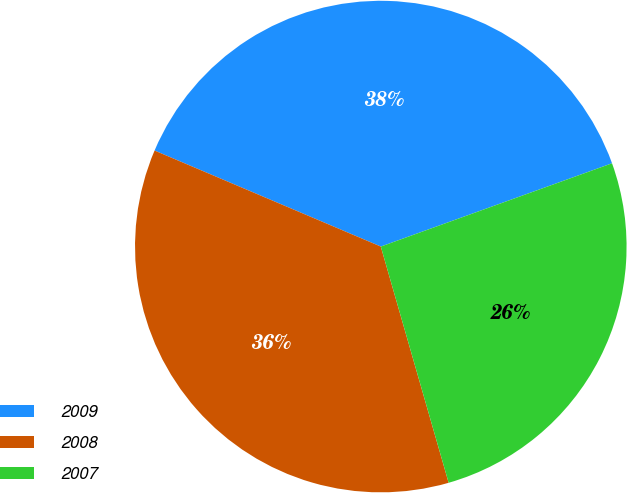<chart> <loc_0><loc_0><loc_500><loc_500><pie_chart><fcel>2009<fcel>2008<fcel>2007<nl><fcel>38.11%<fcel>35.84%<fcel>26.05%<nl></chart> 